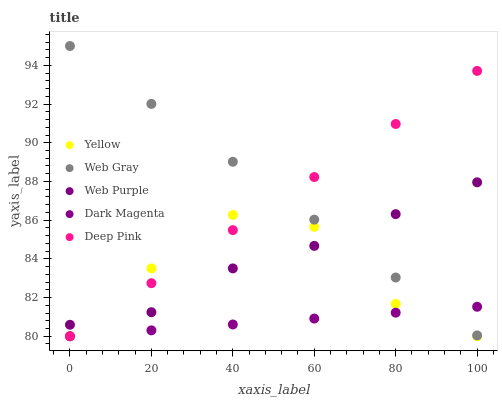Does Dark Magenta have the minimum area under the curve?
Answer yes or no. Yes. Does Web Gray have the maximum area under the curve?
Answer yes or no. Yes. Does Web Gray have the minimum area under the curve?
Answer yes or no. No. Does Dark Magenta have the maximum area under the curve?
Answer yes or no. No. Is Dark Magenta the smoothest?
Answer yes or no. Yes. Is Yellow the roughest?
Answer yes or no. Yes. Is Web Gray the smoothest?
Answer yes or no. No. Is Web Gray the roughest?
Answer yes or no. No. Does Dark Magenta have the lowest value?
Answer yes or no. Yes. Does Web Gray have the lowest value?
Answer yes or no. No. Does Web Gray have the highest value?
Answer yes or no. Yes. Does Dark Magenta have the highest value?
Answer yes or no. No. Is Yellow less than Web Gray?
Answer yes or no. Yes. Is Web Gray greater than Yellow?
Answer yes or no. Yes. Does Web Gray intersect Dark Magenta?
Answer yes or no. Yes. Is Web Gray less than Dark Magenta?
Answer yes or no. No. Is Web Gray greater than Dark Magenta?
Answer yes or no. No. Does Yellow intersect Web Gray?
Answer yes or no. No. 